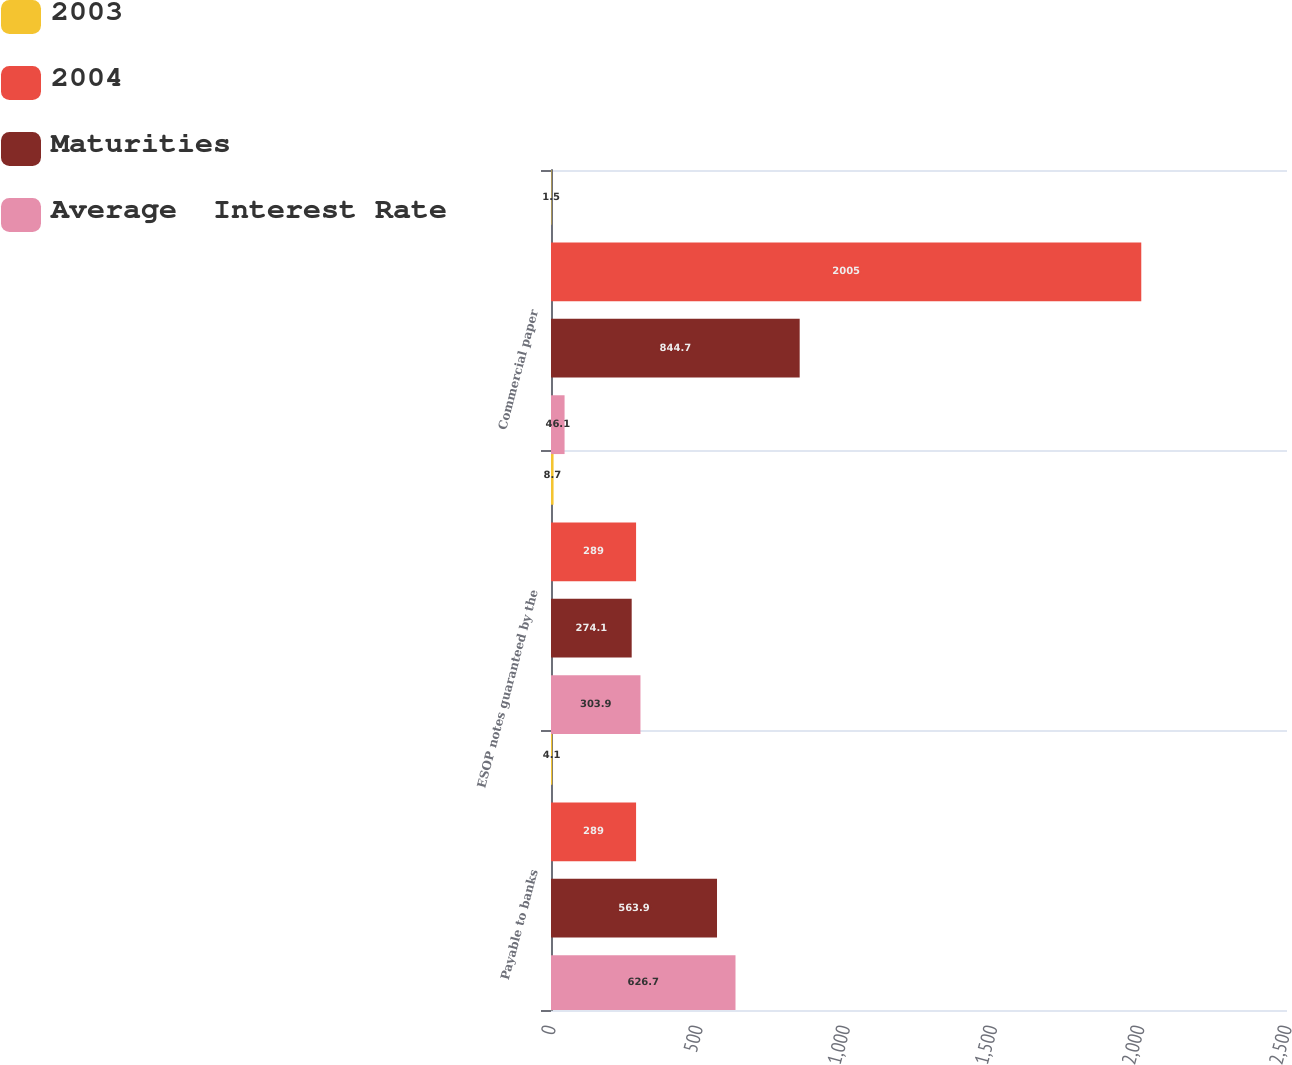Convert chart to OTSL. <chart><loc_0><loc_0><loc_500><loc_500><stacked_bar_chart><ecel><fcel>Payable to banks<fcel>ESOP notes guaranteed by the<fcel>Commercial paper<nl><fcel>2003<fcel>4.1<fcel>8.7<fcel>1.5<nl><fcel>2004<fcel>289<fcel>289<fcel>2005<nl><fcel>Maturities<fcel>563.9<fcel>274.1<fcel>844.7<nl><fcel>Average  Interest Rate<fcel>626.7<fcel>303.9<fcel>46.1<nl></chart> 